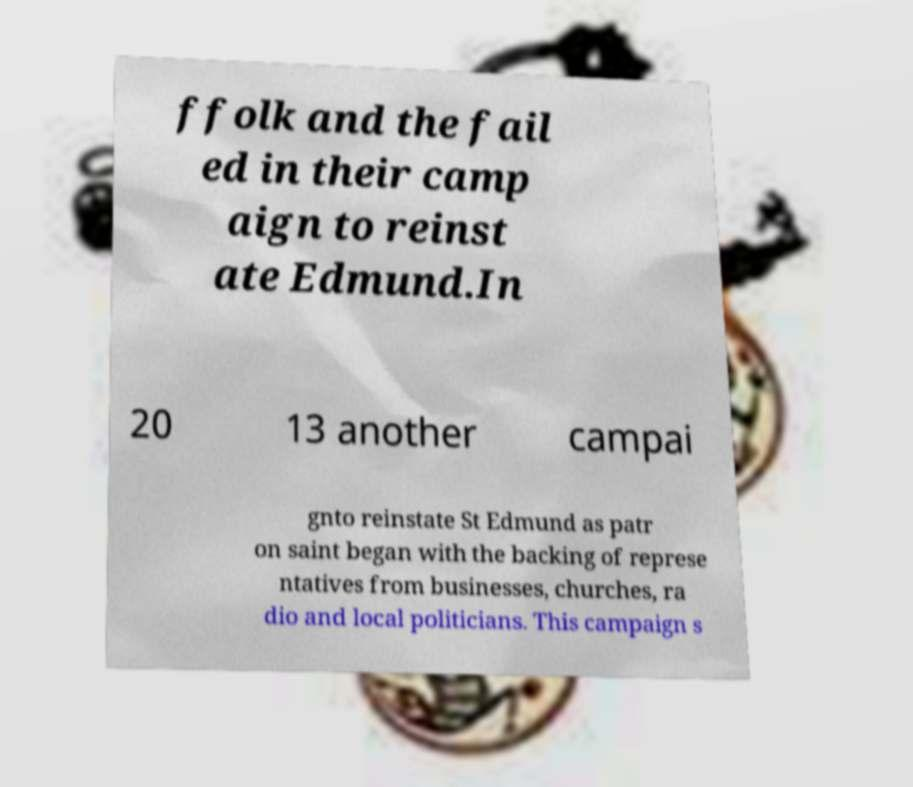Can you accurately transcribe the text from the provided image for me? ffolk and the fail ed in their camp aign to reinst ate Edmund.In 20 13 another campai gnto reinstate St Edmund as patr on saint began with the backing of represe ntatives from businesses, churches, ra dio and local politicians. This campaign s 